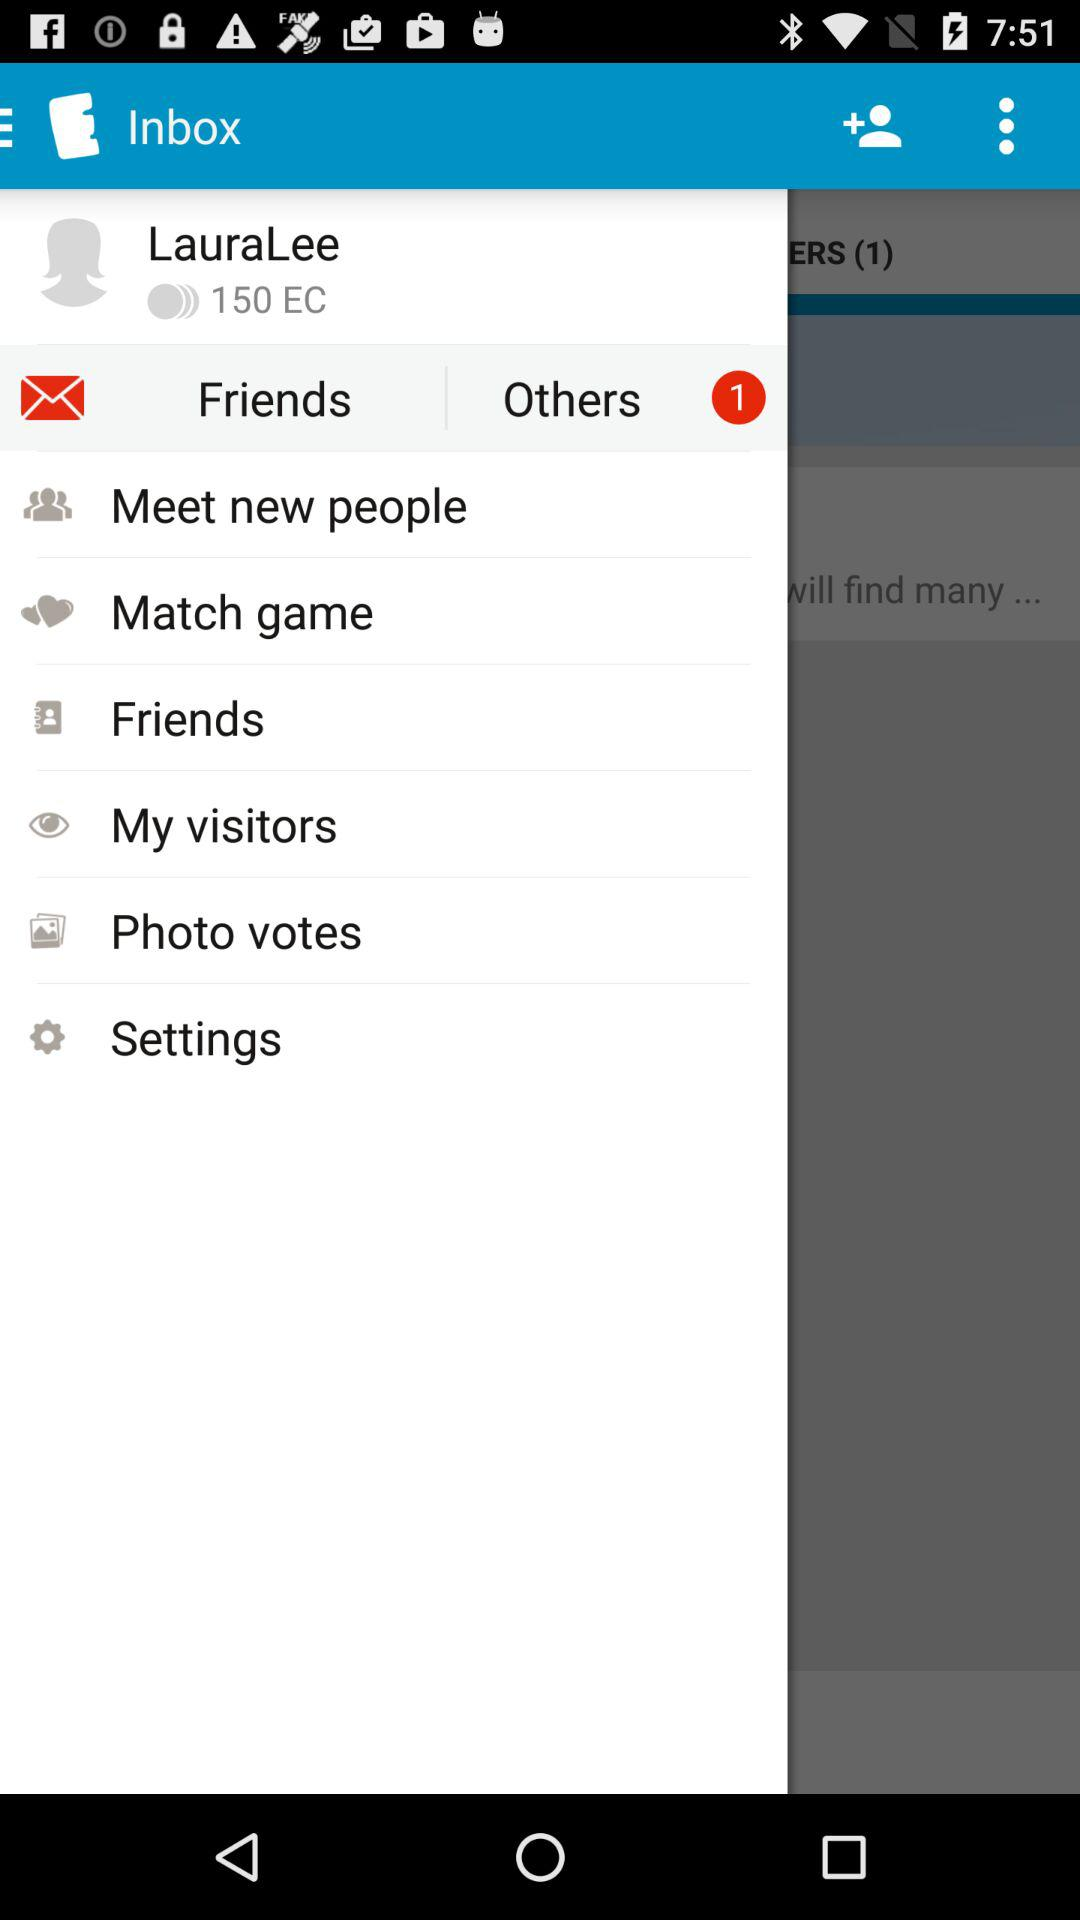How many EC are there? There are 150 EC. 